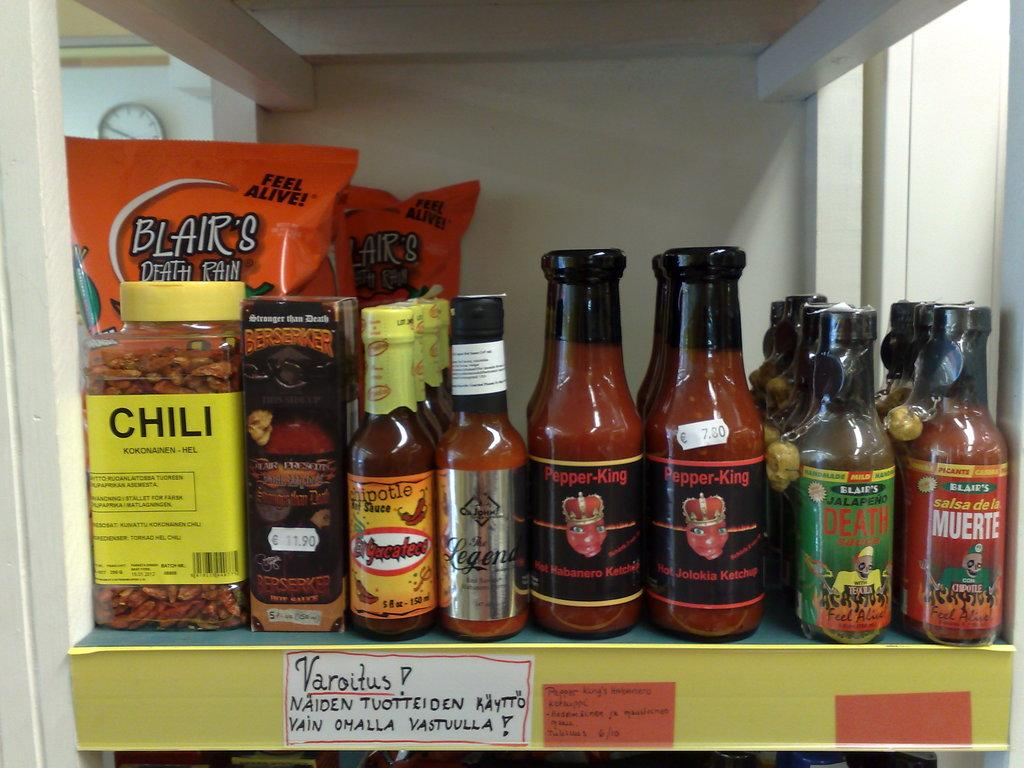Provide a one-sentence caption for the provided image. A shelf with different sized bottles lined up at the end the largest bottle reads Chili. 